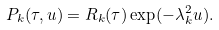Convert formula to latex. <formula><loc_0><loc_0><loc_500><loc_500>P _ { k } ( \tau , u ) = R _ { k } ( \tau ) \exp ( - \lambda _ { k } ^ { 2 } u ) .</formula> 